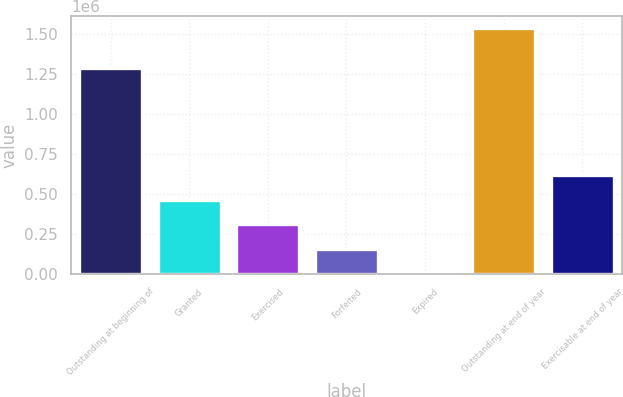Convert chart to OTSL. <chart><loc_0><loc_0><loc_500><loc_500><bar_chart><fcel>Outstanding at beginning of<fcel>Granted<fcel>Exercised<fcel>Forfeited<fcel>Expired<fcel>Outstanding at end of year<fcel>Exercisable at end of year<nl><fcel>1.28772e+06<fcel>463548<fcel>310369<fcel>157189<fcel>4010<fcel>1.5358e+06<fcel>616728<nl></chart> 